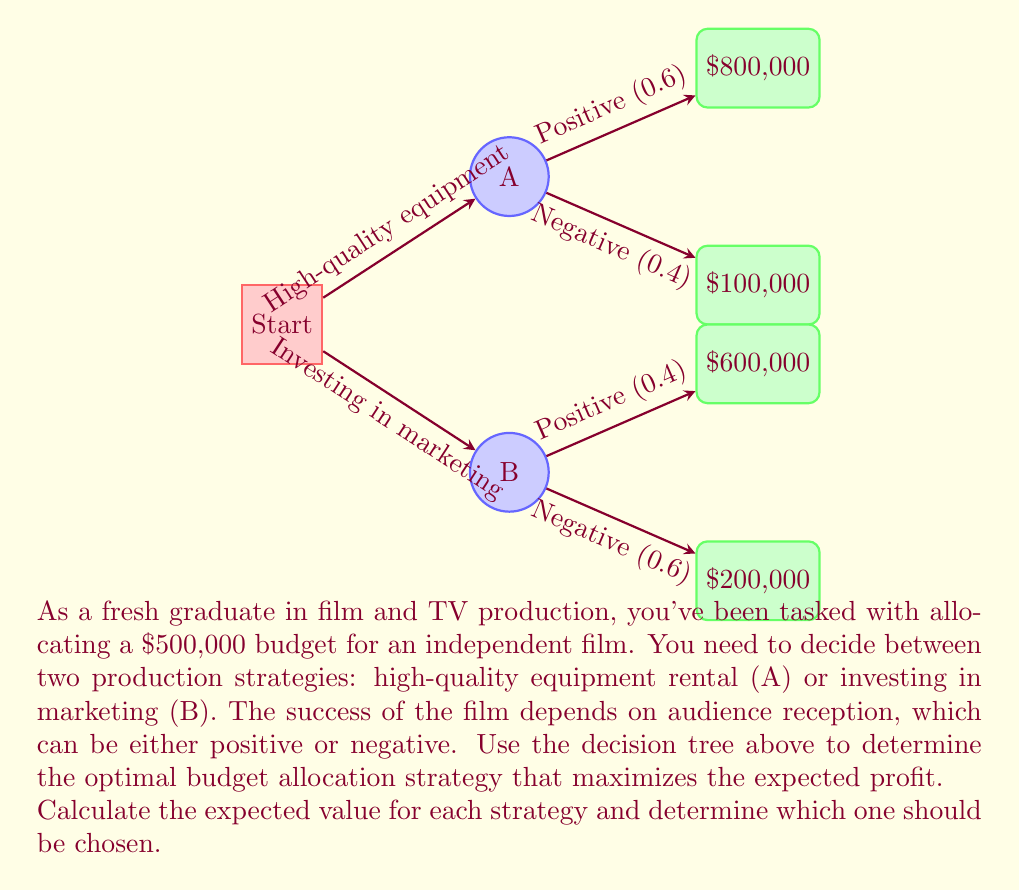Can you answer this question? To solve this problem, we need to calculate the expected value for each strategy using the decision tree provided. Let's break it down step by step:

1. Strategy A: High-quality equipment rental

Expected Value (EV) of Strategy A:
$$EV(A) = (0.6 \times \$800,000) + (0.4 \times \$100,000)$$
$$EV(A) = \$480,000 + \$40,000 = \$520,000$$

2. Strategy B: Investing in marketing

Expected Value (EV) of Strategy B:
$$EV(B) = (0.4 \times \$600,000) + (0.6 \times \$200,000)$$
$$EV(B) = \$240,000 + \$120,000 = \$360,000$$

3. Compare the expected values:

Strategy A: $520,000
Strategy B: $360,000

Since the expected value of Strategy A ($520,000) is higher than the expected value of Strategy B ($360,000), the optimal decision is to choose Strategy A: high-quality equipment rental.

4. Calculate the expected profit:

Initial budget: $500,000
Expected revenue from Strategy A: $520,000
Expected profit: $520,000 - $500,000 = $20,000

Therefore, the optimal budget allocation strategy is to invest in high-quality equipment rental (Strategy A), which is expected to yield a profit of $20,000.
Answer: Choose Strategy A (high-quality equipment rental) for an expected profit of $20,000. 